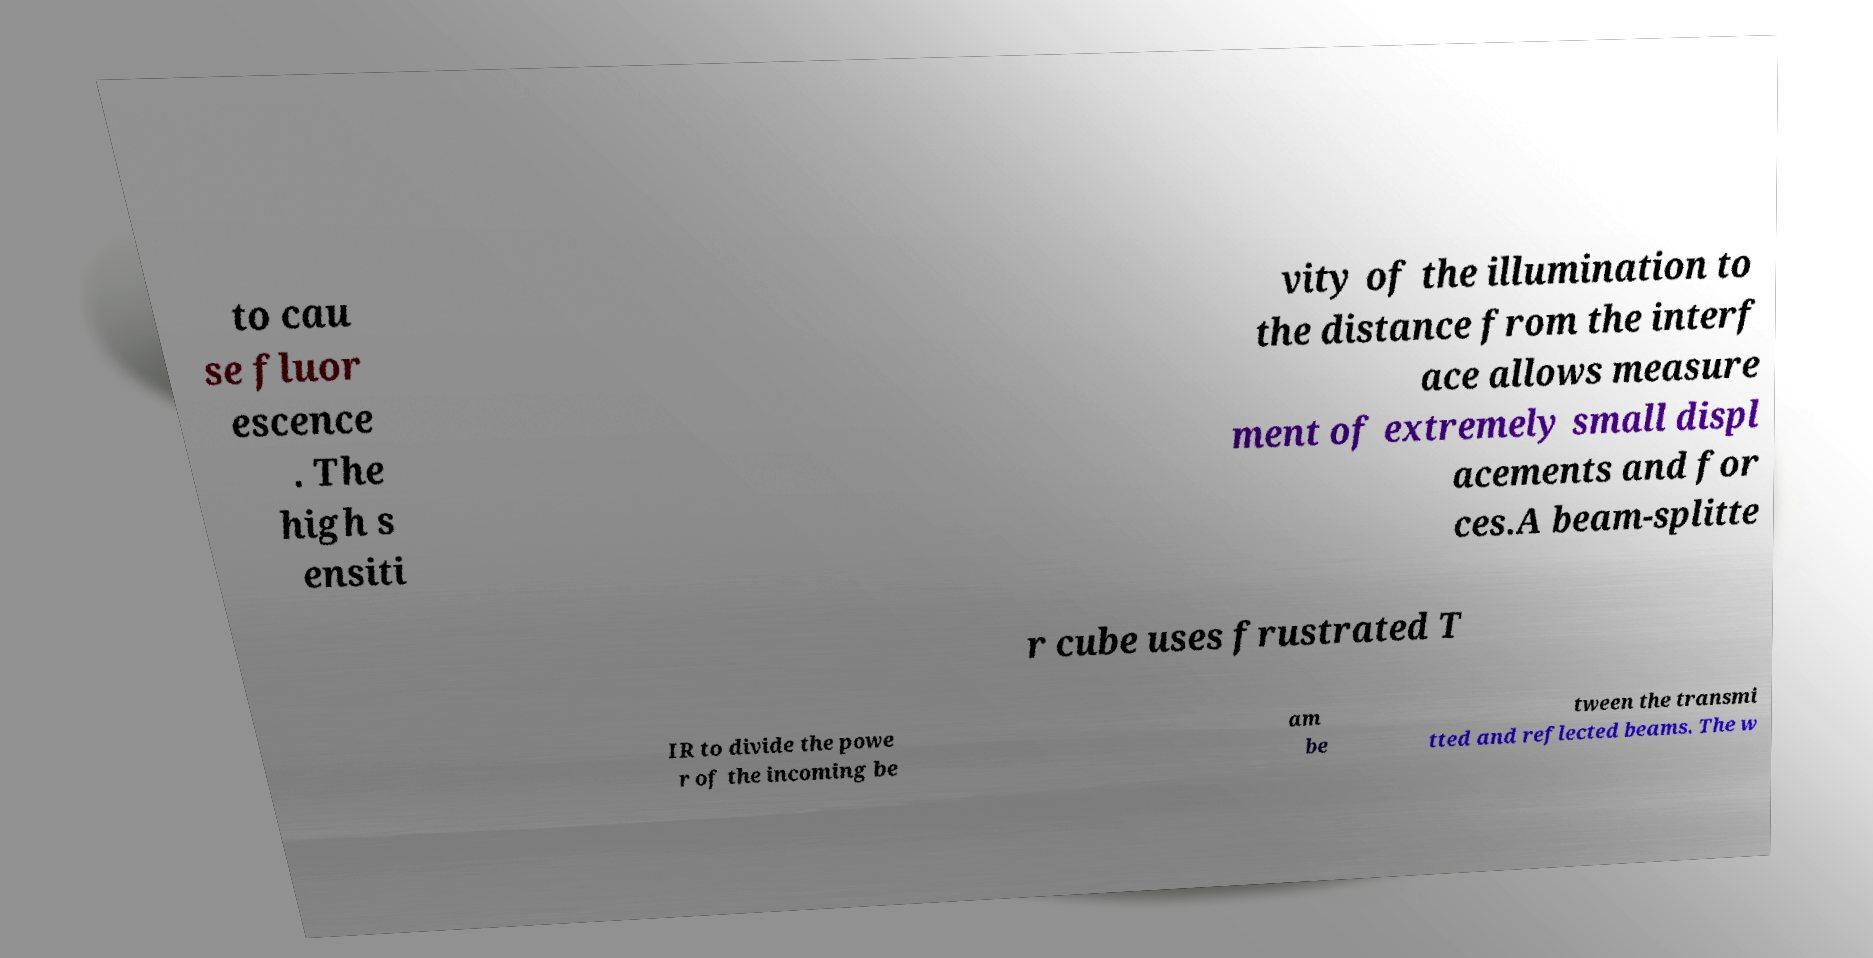Please identify and transcribe the text found in this image. to cau se fluor escence . The high s ensiti vity of the illumination to the distance from the interf ace allows measure ment of extremely small displ acements and for ces.A beam-splitte r cube uses frustrated T IR to divide the powe r of the incoming be am be tween the transmi tted and reflected beams. The w 